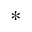Convert formula to latex. <formula><loc_0><loc_0><loc_500><loc_500>^ { * }</formula> 